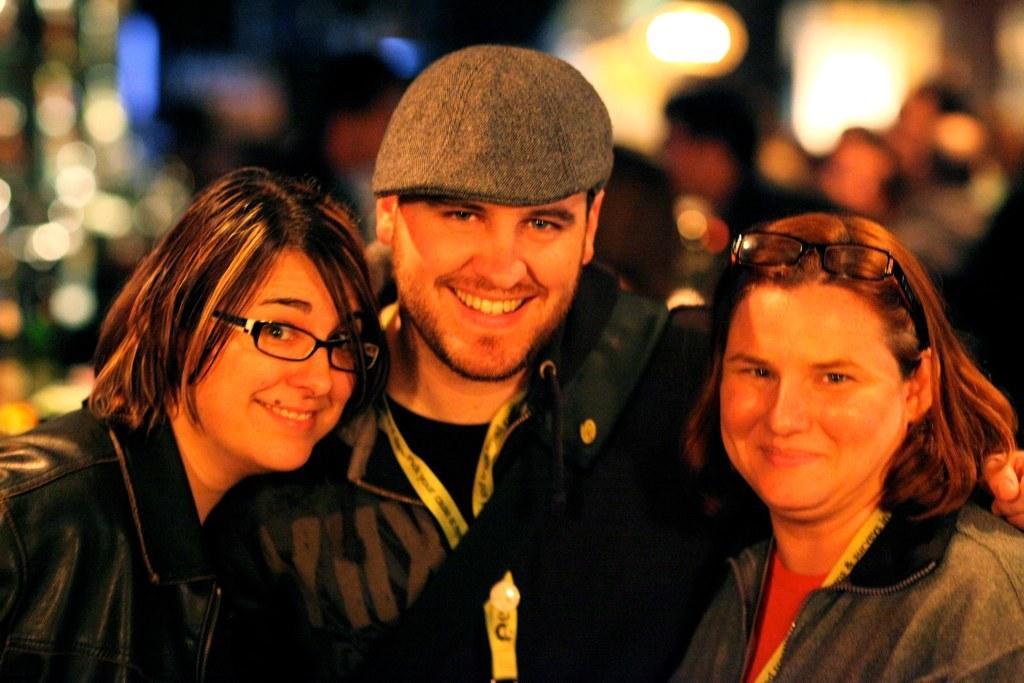Describe this image in one or two sentences. In the foreground I can see three persons. In the background I can see a crowd and lights. This image is taken may be in a hall. 